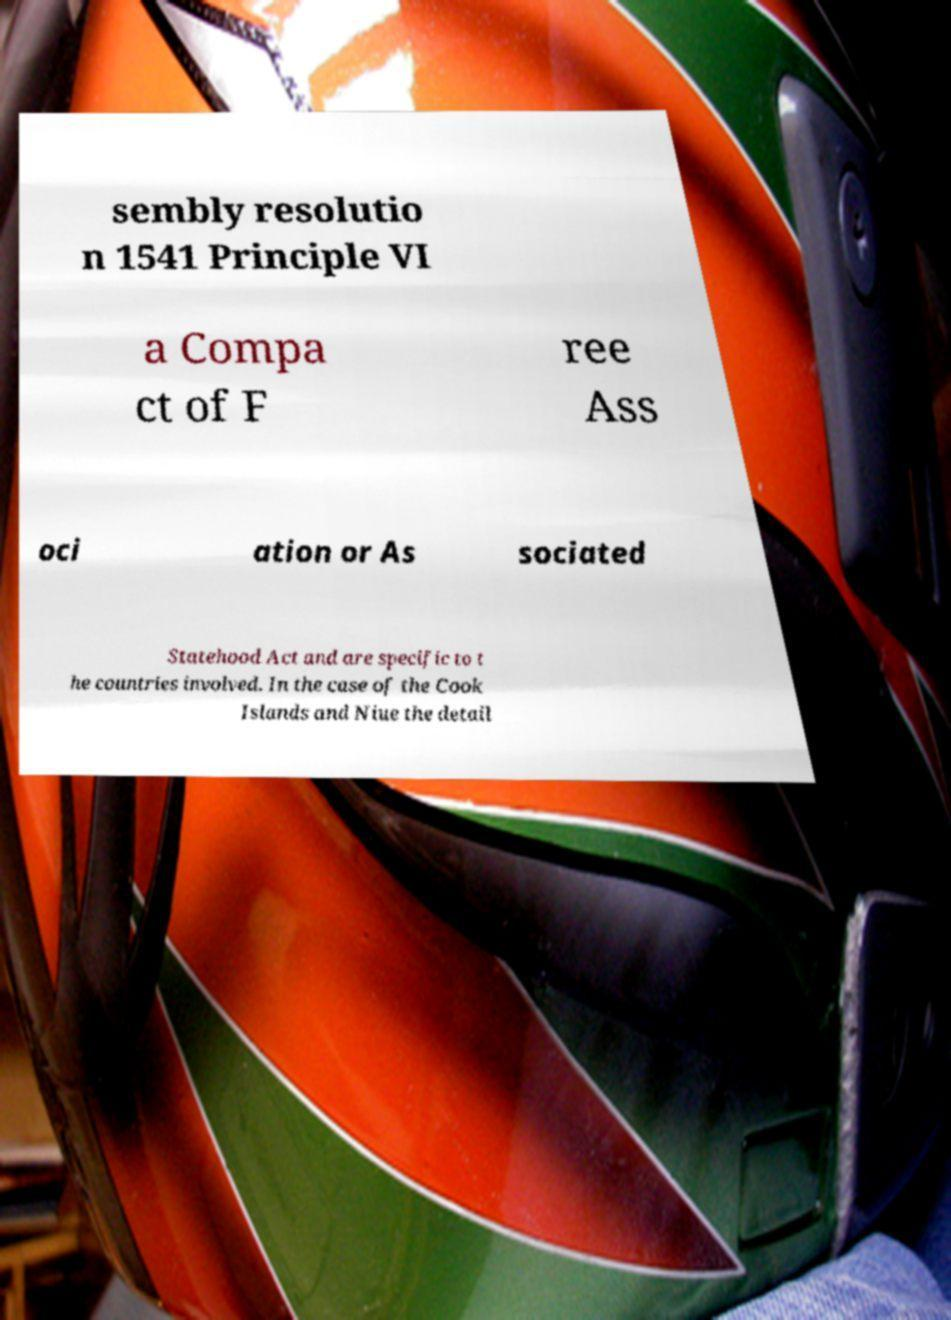What messages or text are displayed in this image? I need them in a readable, typed format. sembly resolutio n 1541 Principle VI a Compa ct of F ree Ass oci ation or As sociated Statehood Act and are specific to t he countries involved. In the case of the Cook Islands and Niue the detail 